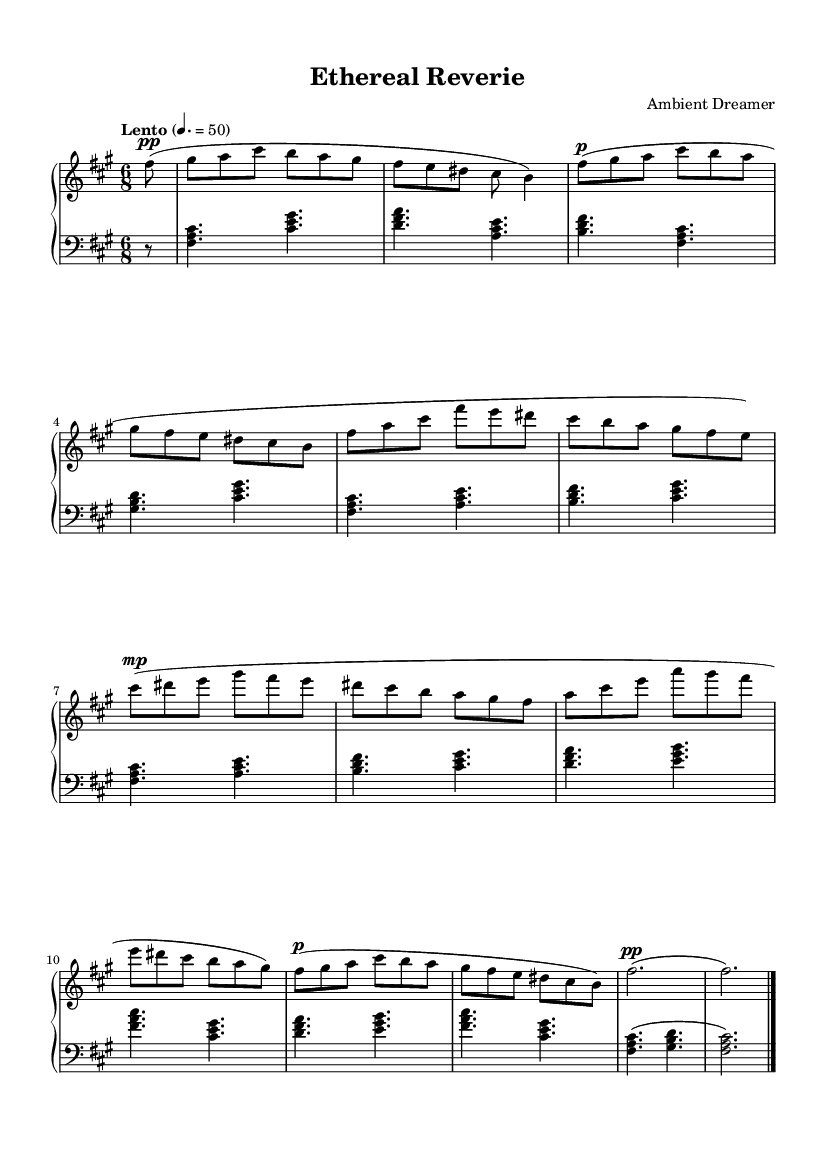What is the key signature of this music? The key signature is indicated at the beginning, where there are three sharps. This corresponds to the key of F# minor.
Answer: F# minor What is the time signature of this music? The time signature is located at the beginning of the score; it is written as 6/8, meaning there are six eighth notes per measure.
Answer: 6/8 What is the tempo marking for this piece? The tempo marking is specified after the key and time signature; it states "Lento" with a metronome marking of 50 for a quarter note, indicating a slow tempo.
Answer: Lento How many distinct themes are present in this piece? The piece consists of two distinct themes labeled as Theme A and Theme B, with Theme A also appearing as an altered version (Theme A'). This accounts for three thematic ideas in total.
Answer: 3 What is the dynamic marking for the introduction section? The introduction section has a dynamic marking of "pp", which indicates it should be played very softly.
Answer: pp In which clef is the upper staff written? The upper staff is indicated to be in the treble clef, which is commonly used for higher pitched instruments and notes.
Answer: Treble clef 